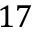<formula> <loc_0><loc_0><loc_500><loc_500>1 7</formula> 